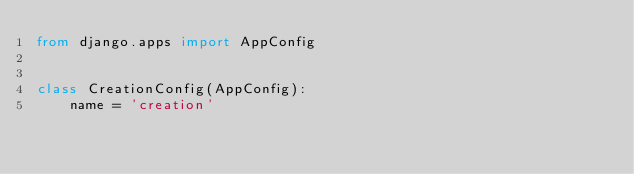Convert code to text. <code><loc_0><loc_0><loc_500><loc_500><_Python_>from django.apps import AppConfig


class CreationConfig(AppConfig):
    name = 'creation'
</code> 